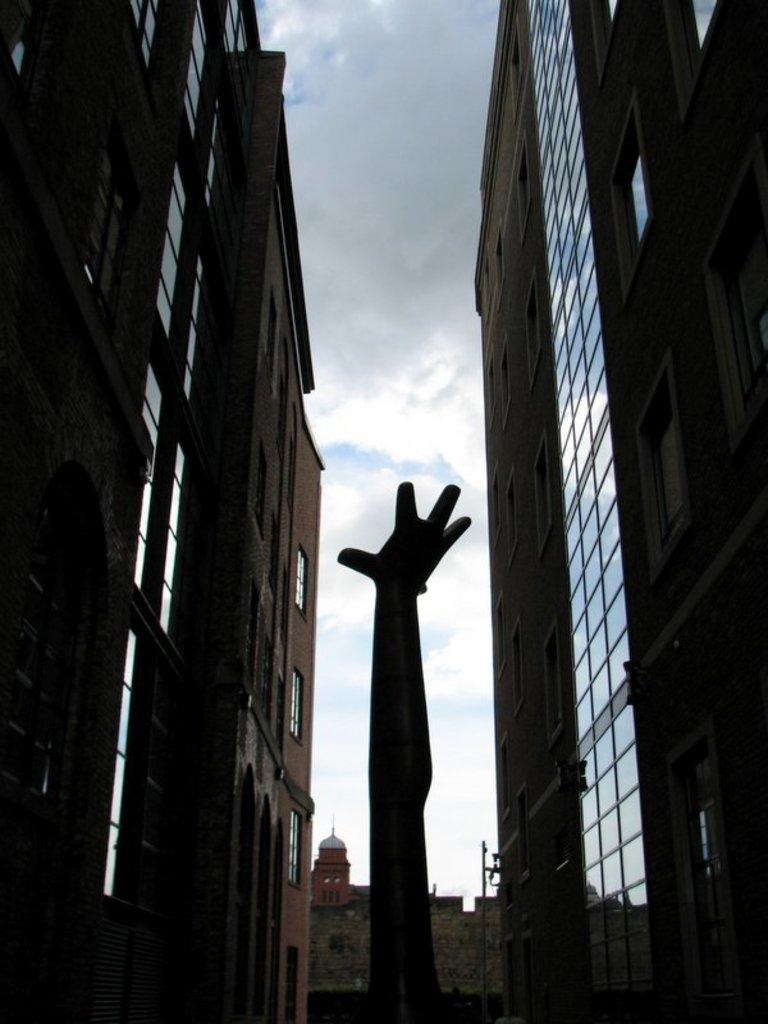What type of structures can be seen in the image? There are buildings in the image. What is the statue in the image depicting? The specific details of the statue are not mentioned, but it is a statue. What is the wall in the image made of? The material of the wall is not specified in the facts. What is visible in the background of the image? The sky is visible in the image. What can be observed in the sky? Clouds are present in the sky. What is the secretary's tendency towards smashing objects in the image? There is no secretary present in the image, and therefore no such behavior can be observed. 